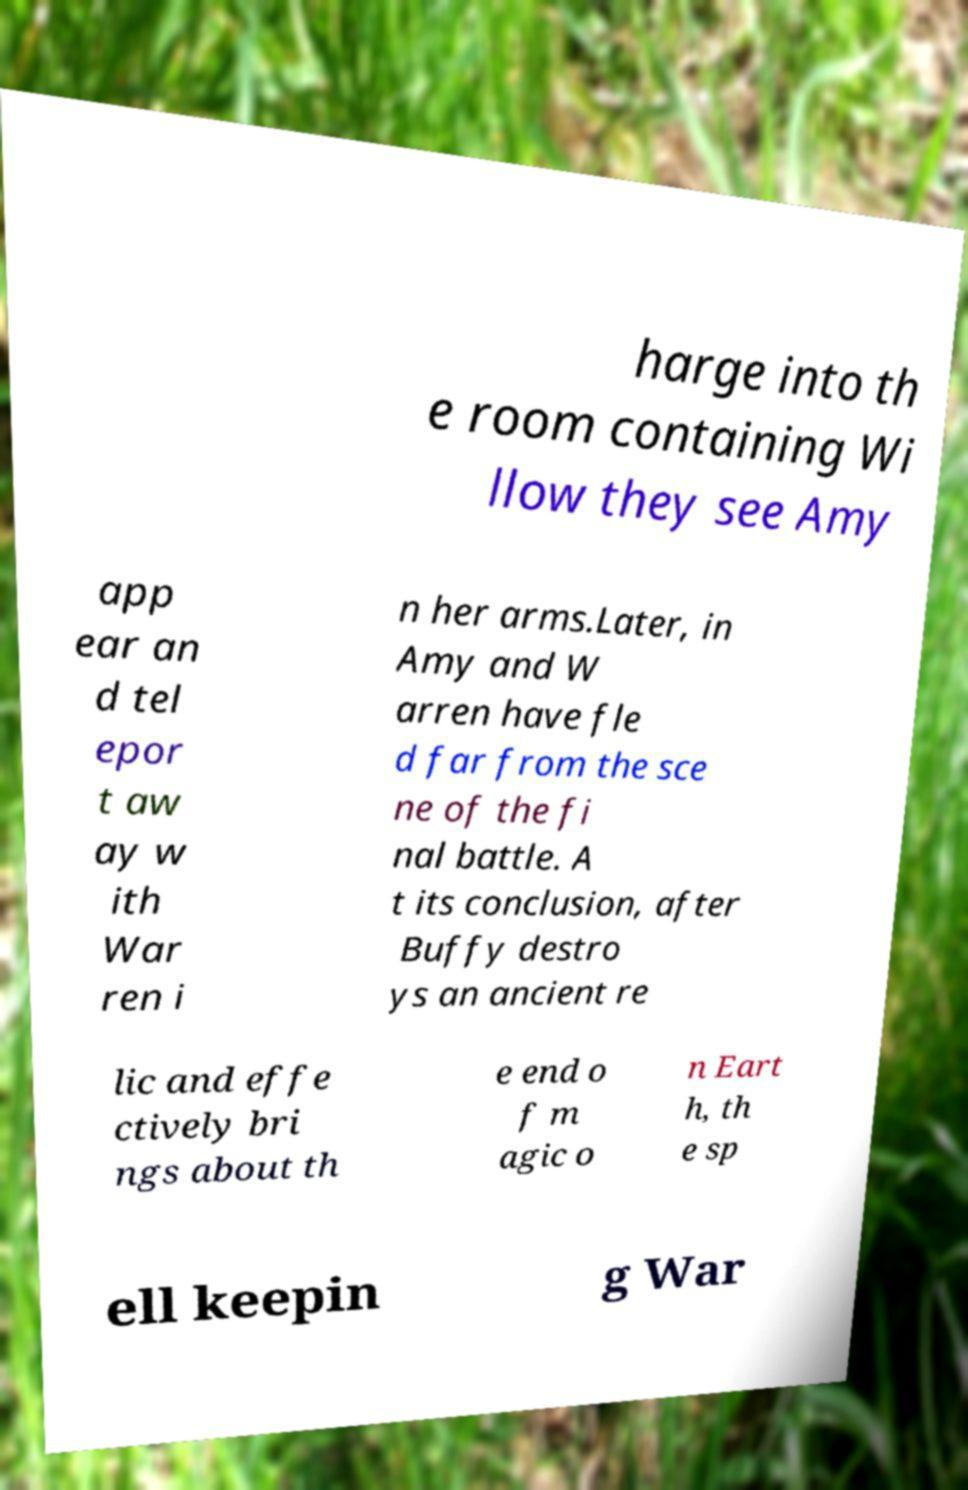Could you extract and type out the text from this image? harge into th e room containing Wi llow they see Amy app ear an d tel epor t aw ay w ith War ren i n her arms.Later, in Amy and W arren have fle d far from the sce ne of the fi nal battle. A t its conclusion, after Buffy destro ys an ancient re lic and effe ctively bri ngs about th e end o f m agic o n Eart h, th e sp ell keepin g War 